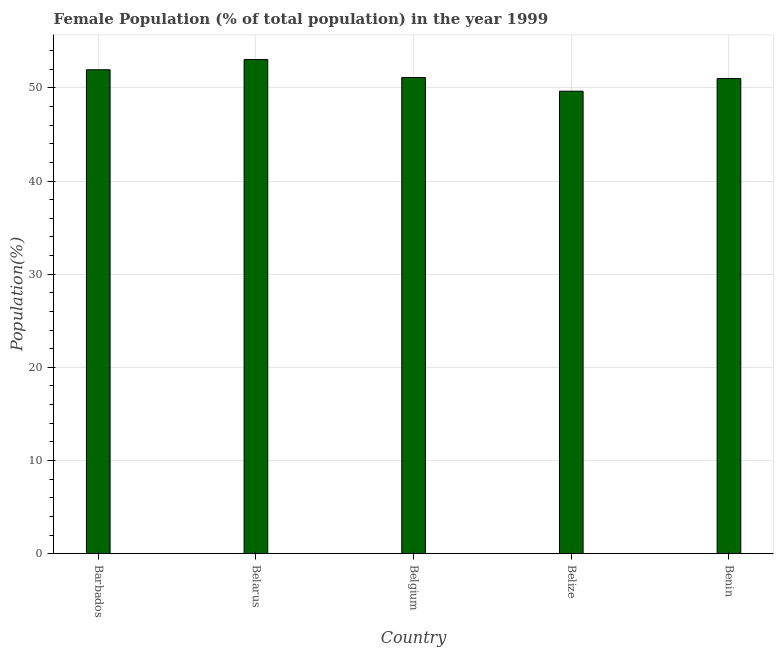What is the title of the graph?
Provide a succinct answer. Female Population (% of total population) in the year 1999. What is the label or title of the Y-axis?
Your answer should be compact. Population(%). What is the female population in Belgium?
Your answer should be compact. 51.11. Across all countries, what is the maximum female population?
Give a very brief answer. 53.04. Across all countries, what is the minimum female population?
Your answer should be compact. 49.64. In which country was the female population maximum?
Offer a terse response. Belarus. In which country was the female population minimum?
Your response must be concise. Belize. What is the sum of the female population?
Give a very brief answer. 256.74. What is the difference between the female population in Barbados and Belgium?
Provide a succinct answer. 0.83. What is the average female population per country?
Your answer should be very brief. 51.35. What is the median female population?
Offer a terse response. 51.11. In how many countries, is the female population greater than 28 %?
Offer a terse response. 5. What is the ratio of the female population in Barbados to that in Benin?
Offer a terse response. 1.02. Is the female population in Belarus less than that in Belgium?
Offer a terse response. No. Is the difference between the female population in Belize and Benin greater than the difference between any two countries?
Offer a terse response. No. What is the difference between the highest and the second highest female population?
Your response must be concise. 1.09. Is the sum of the female population in Barbados and Belarus greater than the maximum female population across all countries?
Give a very brief answer. Yes. What is the difference between the highest and the lowest female population?
Offer a terse response. 3.39. How many bars are there?
Keep it short and to the point. 5. How many countries are there in the graph?
Make the answer very short. 5. What is the difference between two consecutive major ticks on the Y-axis?
Your answer should be compact. 10. What is the Population(%) in Barbados?
Keep it short and to the point. 51.94. What is the Population(%) in Belarus?
Provide a short and direct response. 53.04. What is the Population(%) of Belgium?
Offer a terse response. 51.11. What is the Population(%) of Belize?
Offer a very short reply. 49.64. What is the Population(%) of Benin?
Give a very brief answer. 51. What is the difference between the Population(%) in Barbados and Belarus?
Make the answer very short. -1.09. What is the difference between the Population(%) in Barbados and Belgium?
Offer a terse response. 0.83. What is the difference between the Population(%) in Barbados and Belize?
Give a very brief answer. 2.3. What is the difference between the Population(%) in Barbados and Benin?
Offer a very short reply. 0.94. What is the difference between the Population(%) in Belarus and Belgium?
Your response must be concise. 1.93. What is the difference between the Population(%) in Belarus and Belize?
Keep it short and to the point. 3.39. What is the difference between the Population(%) in Belarus and Benin?
Offer a terse response. 2.04. What is the difference between the Population(%) in Belgium and Belize?
Make the answer very short. 1.47. What is the difference between the Population(%) in Belgium and Benin?
Provide a short and direct response. 0.11. What is the difference between the Population(%) in Belize and Benin?
Give a very brief answer. -1.36. What is the ratio of the Population(%) in Barbados to that in Belize?
Make the answer very short. 1.05. What is the ratio of the Population(%) in Barbados to that in Benin?
Give a very brief answer. 1.02. What is the ratio of the Population(%) in Belarus to that in Belgium?
Provide a short and direct response. 1.04. What is the ratio of the Population(%) in Belarus to that in Belize?
Your answer should be compact. 1.07. 